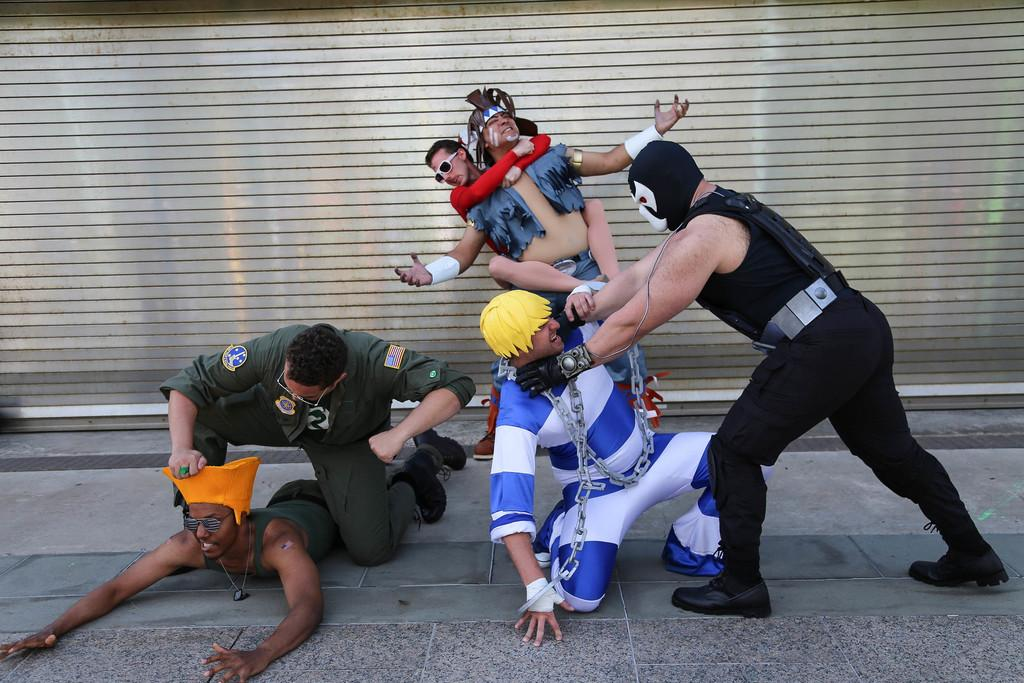Where was the image taken? The image was clicked outside. What is happening in the foreground of the image? There is a group of persons in the foreground, and they appear to be fighting with each other. What can be seen in the background of the image? There is a shutter in the background. What page of the book are the persons reading in the image? There is no book or page visible in the image; the persons are fighting with each other. 